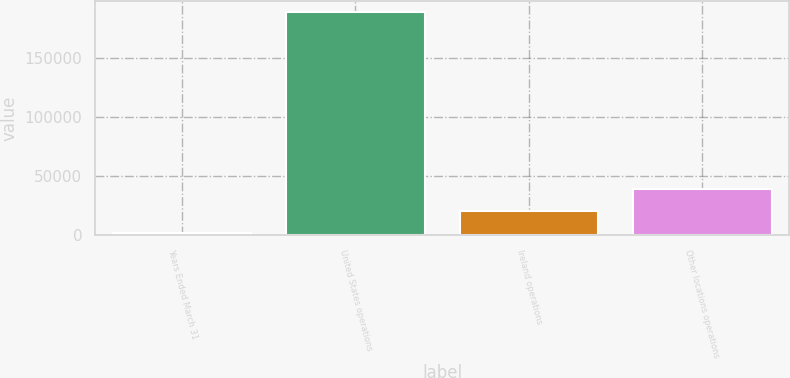Convert chart. <chart><loc_0><loc_0><loc_500><loc_500><bar_chart><fcel>Years Ended March 31<fcel>United States operations<fcel>Ireland operations<fcel>Other locations operations<nl><fcel>2017<fcel>189429<fcel>20758.2<fcel>39499.4<nl></chart> 